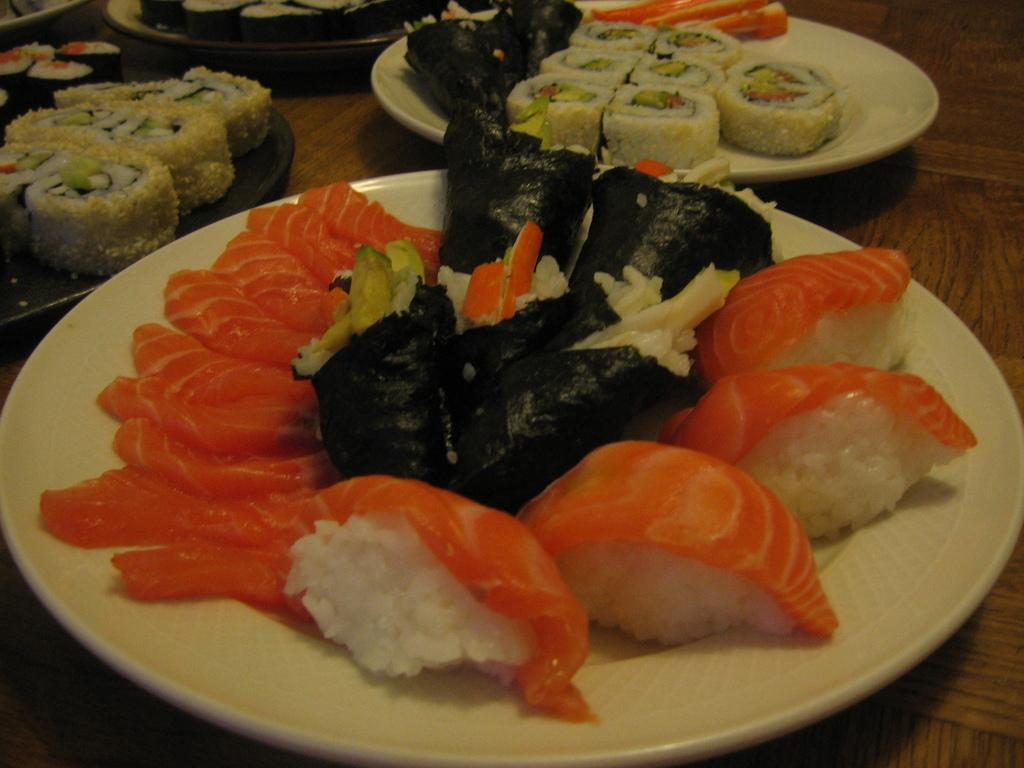What objects are present on the wooden surface in the image? There are plates on the wooden surface in the image. What is the material of the surface where the plates are placed? The surface is made of wood. What can be found on top of the plates? There are food items on the plates. How many eyes can be seen on the plates in the image? There are no eyes present on the plates in the image. 